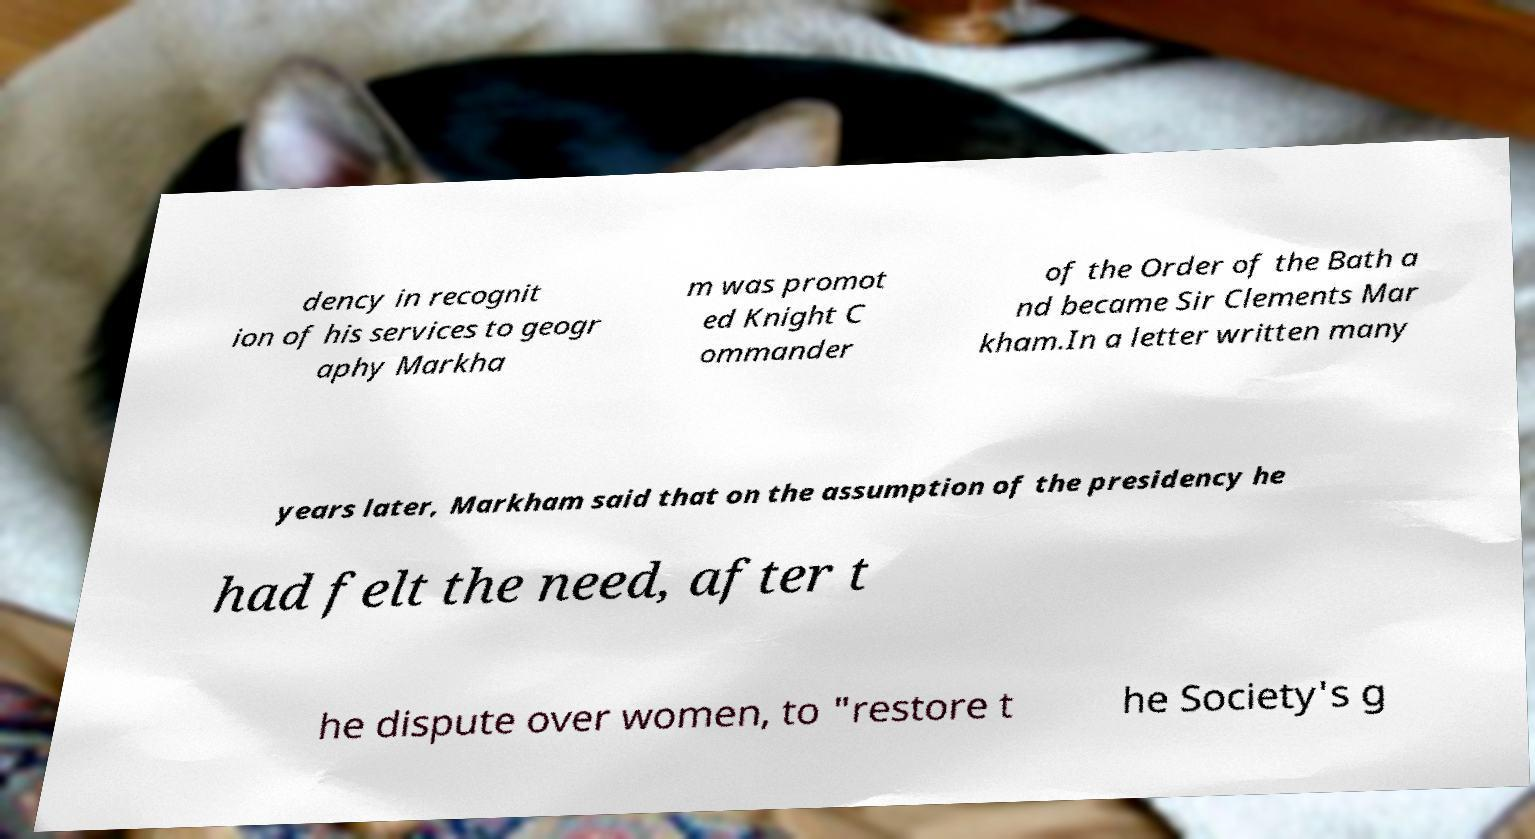There's text embedded in this image that I need extracted. Can you transcribe it verbatim? dency in recognit ion of his services to geogr aphy Markha m was promot ed Knight C ommander of the Order of the Bath a nd became Sir Clements Mar kham.In a letter written many years later, Markham said that on the assumption of the presidency he had felt the need, after t he dispute over women, to "restore t he Society's g 